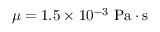Convert formula to latex. <formula><loc_0><loc_0><loc_500><loc_500>\mu = 1 . 5 \times 1 0 ^ { - 3 } P a \cdot s</formula> 